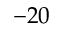Convert formula to latex. <formula><loc_0><loc_0><loc_500><loc_500>- 2 0</formula> 